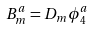<formula> <loc_0><loc_0><loc_500><loc_500>B ^ { a } _ { m } = D _ { m } \phi ^ { a } _ { 4 }</formula> 